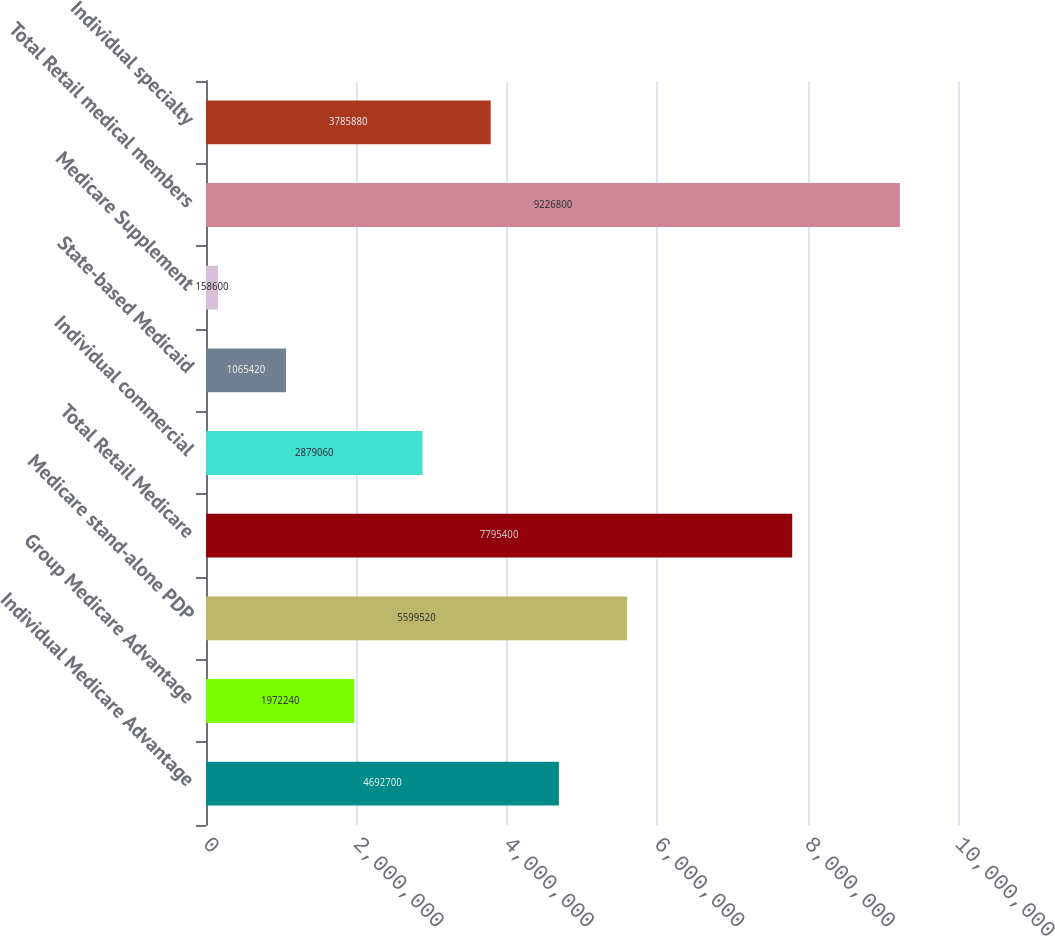Convert chart. <chart><loc_0><loc_0><loc_500><loc_500><bar_chart><fcel>Individual Medicare Advantage<fcel>Group Medicare Advantage<fcel>Medicare stand-alone PDP<fcel>Total Retail Medicare<fcel>Individual commercial<fcel>State-based Medicaid<fcel>Medicare Supplement<fcel>Total Retail medical members<fcel>Individual specialty<nl><fcel>4.6927e+06<fcel>1.97224e+06<fcel>5.59952e+06<fcel>7.7954e+06<fcel>2.87906e+06<fcel>1.06542e+06<fcel>158600<fcel>9.2268e+06<fcel>3.78588e+06<nl></chart> 